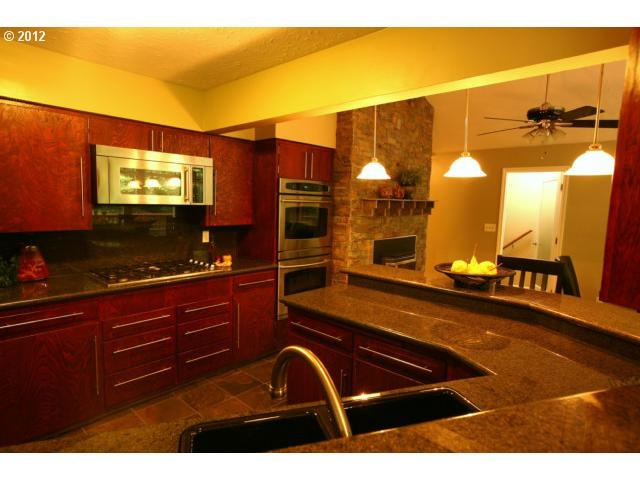Please transcribe the text in this image. 2012 